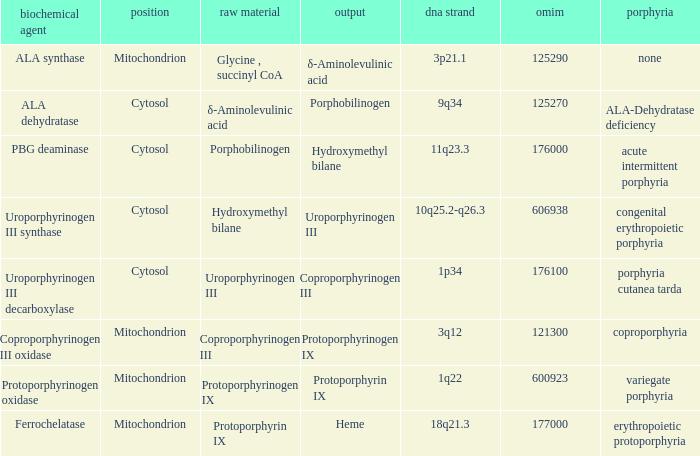What is protoporphyrin ix's substrate? Protoporphyrinogen IX. 